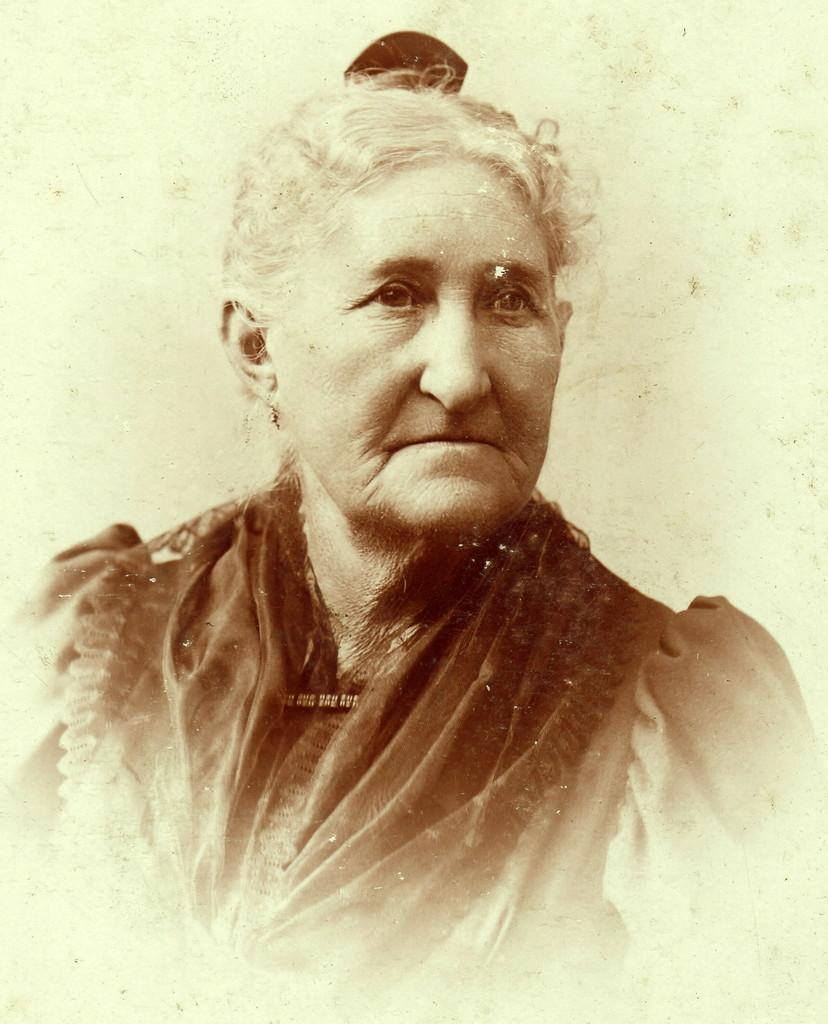What type of image is present in the picture? The image contains a black and white photograph. What is the subject of the photograph? The photograph depicts a woman. What type of fish can be seen swimming in the field in the image? There is no fish or field present in the image; it contains a black and white photograph of a woman. 